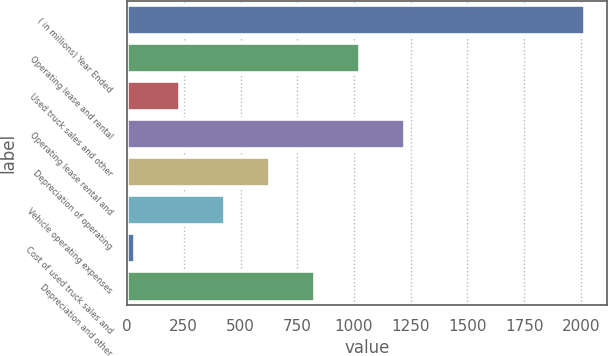Convert chart to OTSL. <chart><loc_0><loc_0><loc_500><loc_500><bar_chart><fcel>( in millions) Year Ended<fcel>Operating lease and rental<fcel>Used truck sales and other<fcel>Operating lease rental and<fcel>Depreciation of operating<fcel>Vehicle operating expenses<fcel>Cost of used truck sales and<fcel>Depreciation and other<nl><fcel>2016<fcel>1025<fcel>232.2<fcel>1223.2<fcel>628.6<fcel>430.4<fcel>34<fcel>826.8<nl></chart> 